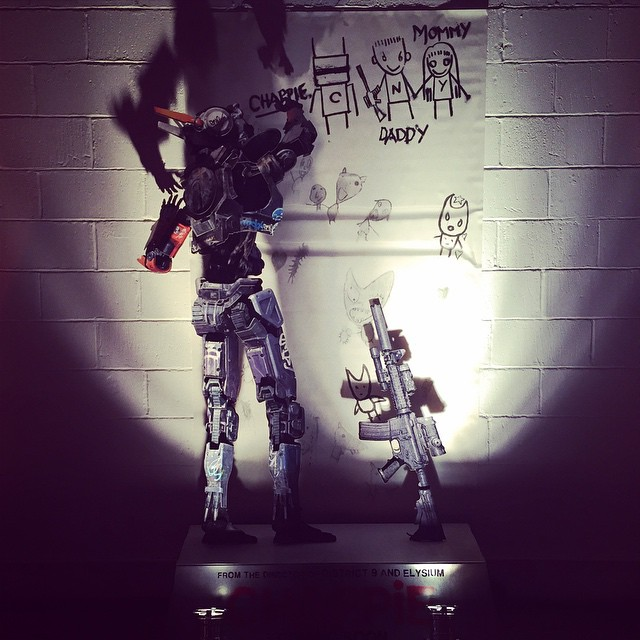What do you think is the significance of the robot's posture and actions in the context of the surrounding drawings? The robot's posture, standing in front of the wall adorned with child-like drawings, suggests an interaction with the drawings. Its raised arm and hand placement hint at a protective or reflective gesture, as if acknowledging or contemplating the significance of the artwork created by a child. This situational setup may indicate a narrative where the robot plays a guardian-like role, fostering a sense of safety and care in its environment. It also visually bridges the gap between cold, mechanical precision and the warmth of childlike creativity, emphasizing the robot’s potential role within a domestic, nurturing context. 